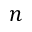<formula> <loc_0><loc_0><loc_500><loc_500>n</formula> 